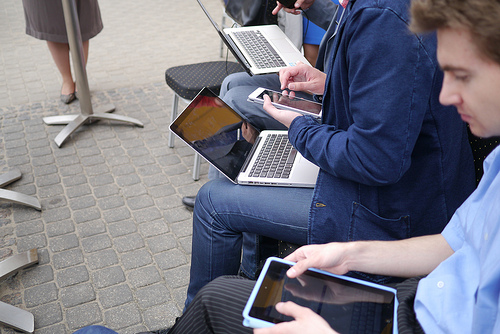Describe the activity taking place in this image. Several individuals are gathered using their electronic devices, which suggests a scene of technological engagement or a casual business meeting outdoors. Can you tell me more about the setting of this gathering? Certainly! The setting appears to be an outdoor area, possibly a café or an open-air workspace, designed to accommodate informal business discussions or remote working scenarios. 